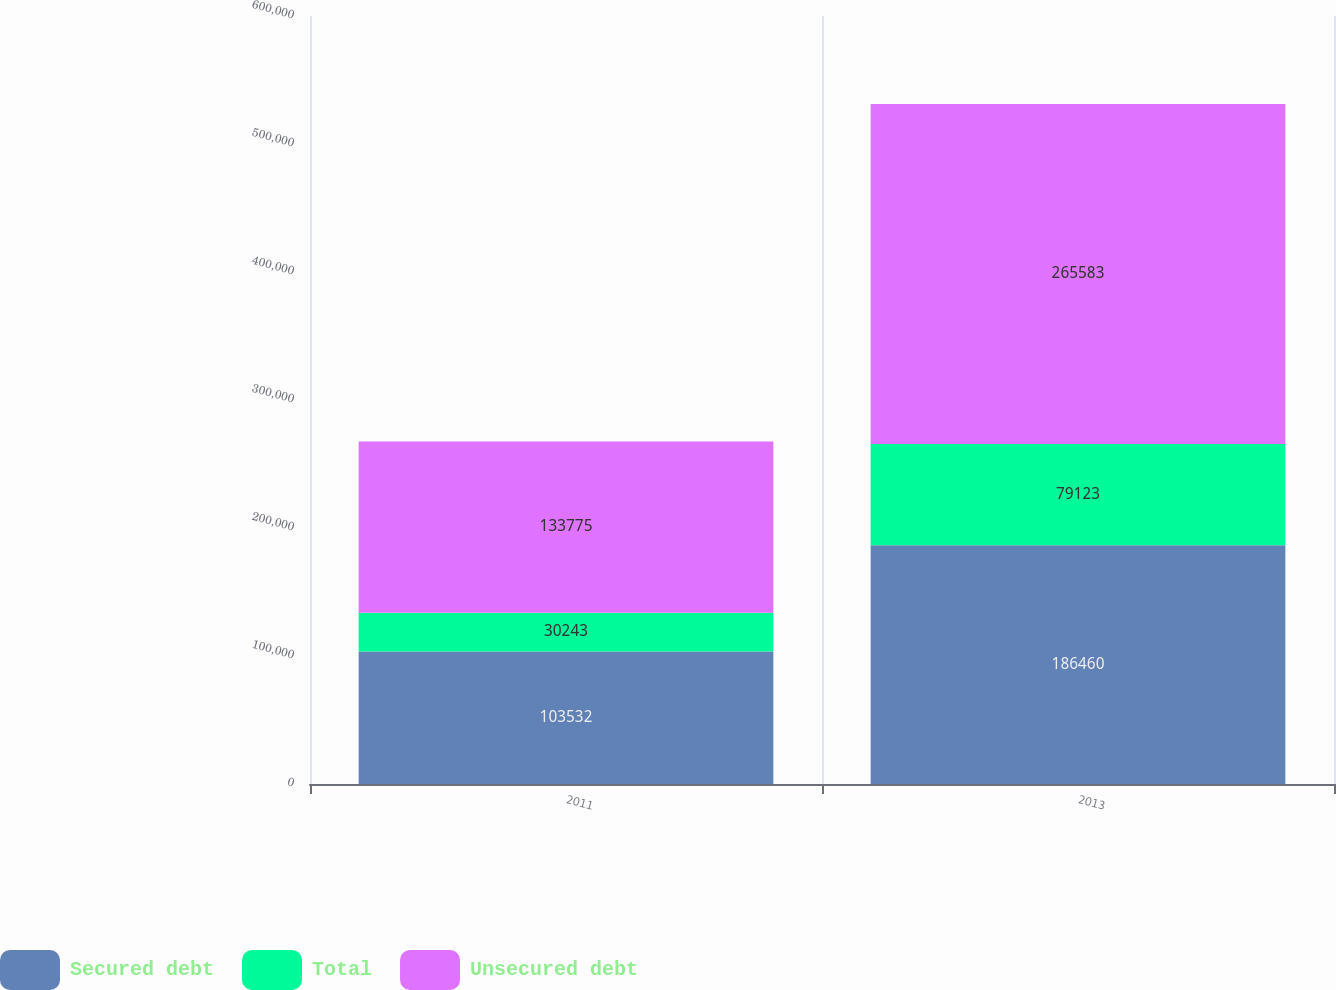Convert chart to OTSL. <chart><loc_0><loc_0><loc_500><loc_500><stacked_bar_chart><ecel><fcel>2011<fcel>2013<nl><fcel>Secured debt<fcel>103532<fcel>186460<nl><fcel>Total<fcel>30243<fcel>79123<nl><fcel>Unsecured debt<fcel>133775<fcel>265583<nl></chart> 